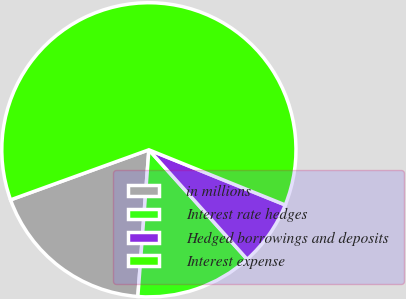Convert chart. <chart><loc_0><loc_0><loc_500><loc_500><pie_chart><fcel>in millions<fcel>Interest rate hedges<fcel>Hedged borrowings and deposits<fcel>Interest expense<nl><fcel>18.28%<fcel>12.84%<fcel>7.24%<fcel>61.64%<nl></chart> 